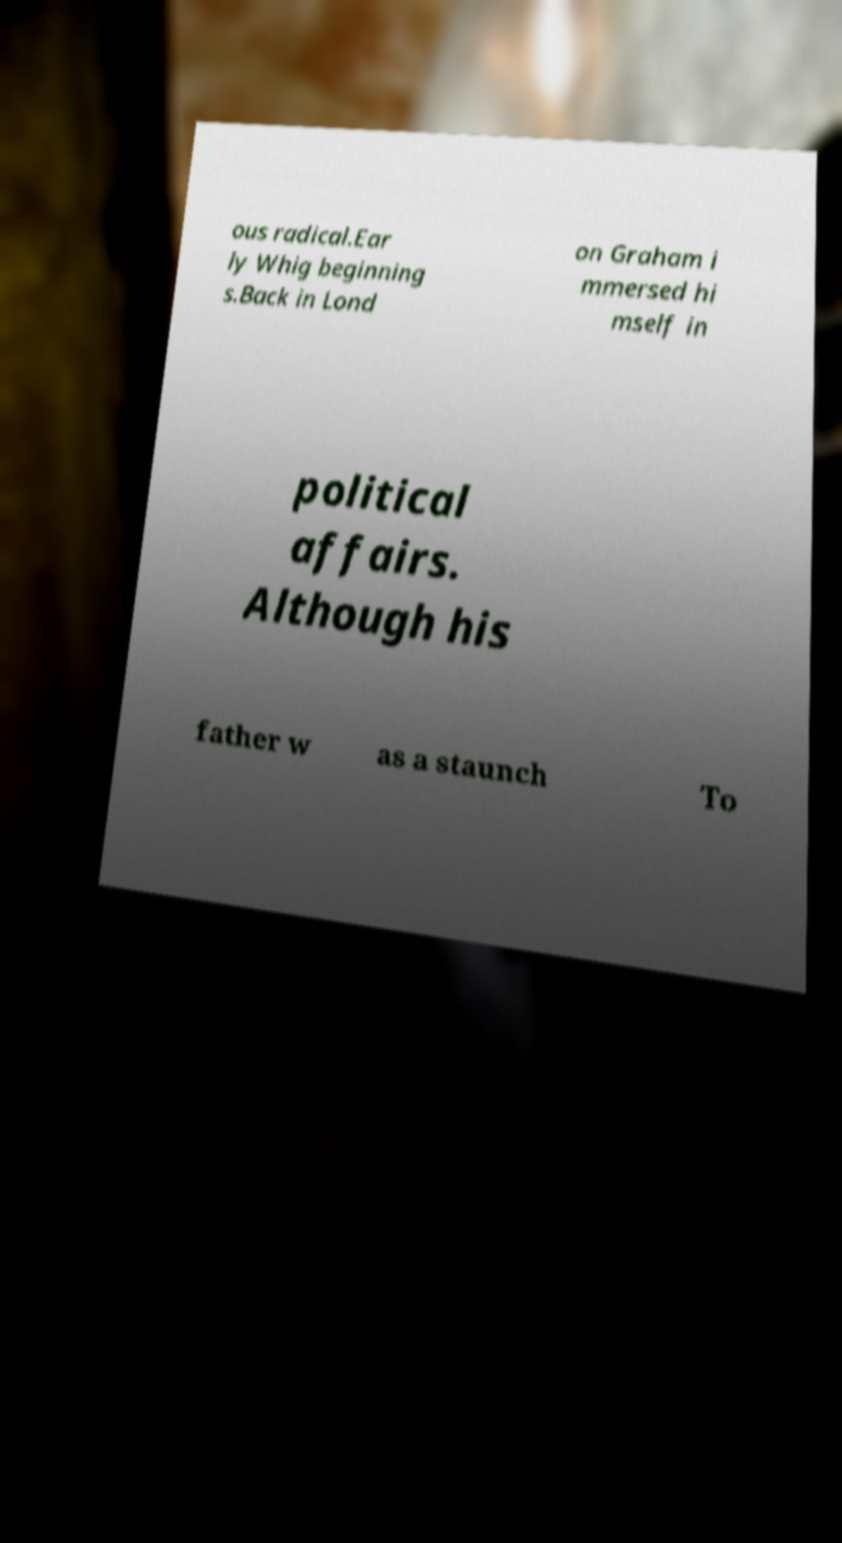Please read and relay the text visible in this image. What does it say? ous radical.Ear ly Whig beginning s.Back in Lond on Graham i mmersed hi mself in political affairs. Although his father w as a staunch To 